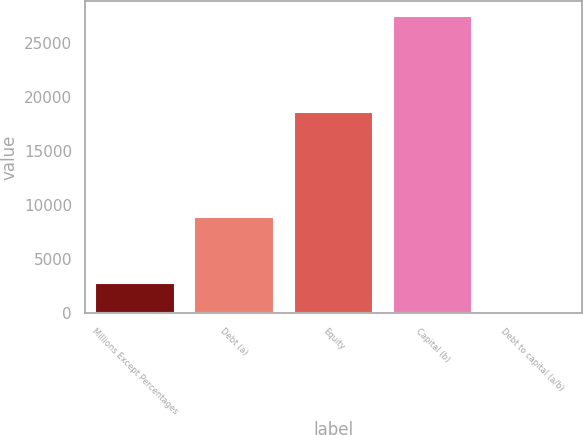Convert chart to OTSL. <chart><loc_0><loc_0><loc_500><loc_500><bar_chart><fcel>Millions Except Percentages<fcel>Debt (a)<fcel>Equity<fcel>Capital (b)<fcel>Debt to capital (a/b)<nl><fcel>2777.56<fcel>8906<fcel>18578<fcel>27484<fcel>32.4<nl></chart> 